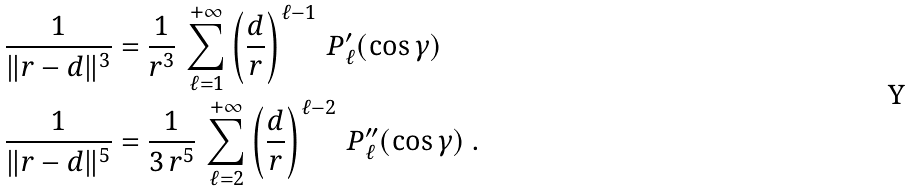<formula> <loc_0><loc_0><loc_500><loc_500>\frac { 1 } { \| r - d \| ^ { 3 } } & = \frac { 1 } { r ^ { 3 } } \, \sum _ { \ell = 1 } ^ { + \infty } \left ( \frac { d } { r } \right ) ^ { \ell - 1 } \, P ^ { \prime } _ { \ell } ( \cos \gamma ) \\ \frac { 1 } { \| r - d \| ^ { 5 } } & = \frac { 1 } { 3 \, r ^ { 5 } } \, \sum _ { \ell = 2 } ^ { + \infty } \left ( \frac { d } { r } \right ) ^ { \ell - 2 } \, P ^ { \prime \prime } _ { \ell } ( \cos \gamma ) \ .</formula> 